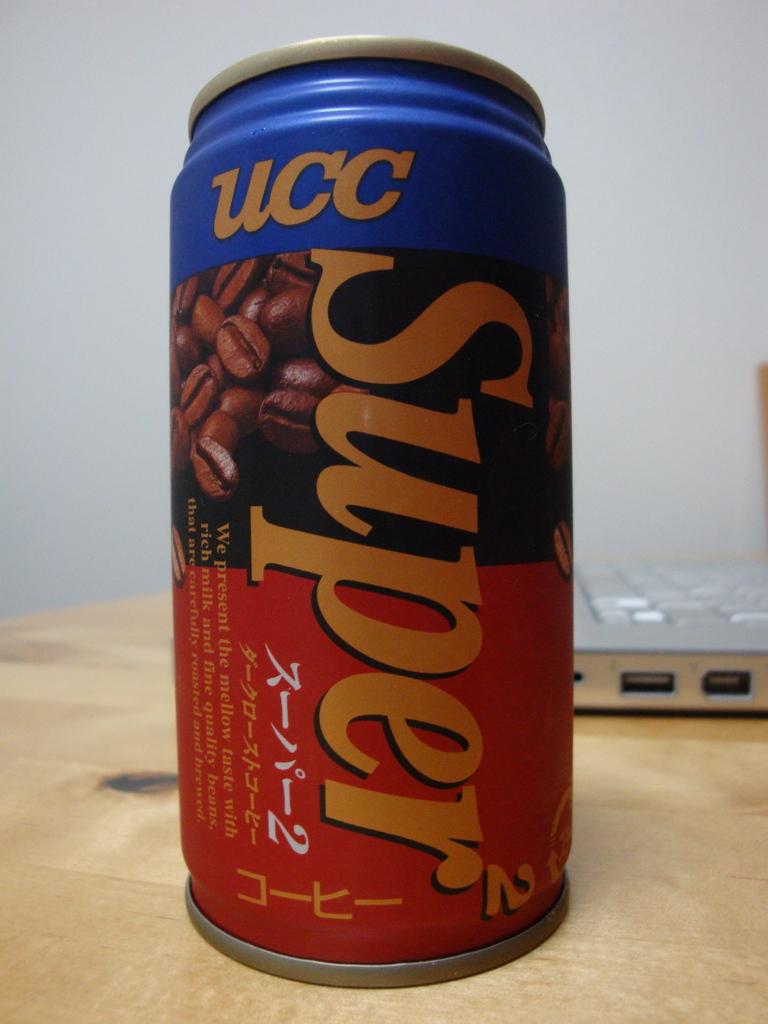What is the name of this drink?
Make the answer very short. Super. What letters are at the top?
Ensure brevity in your answer.  Ucc. 